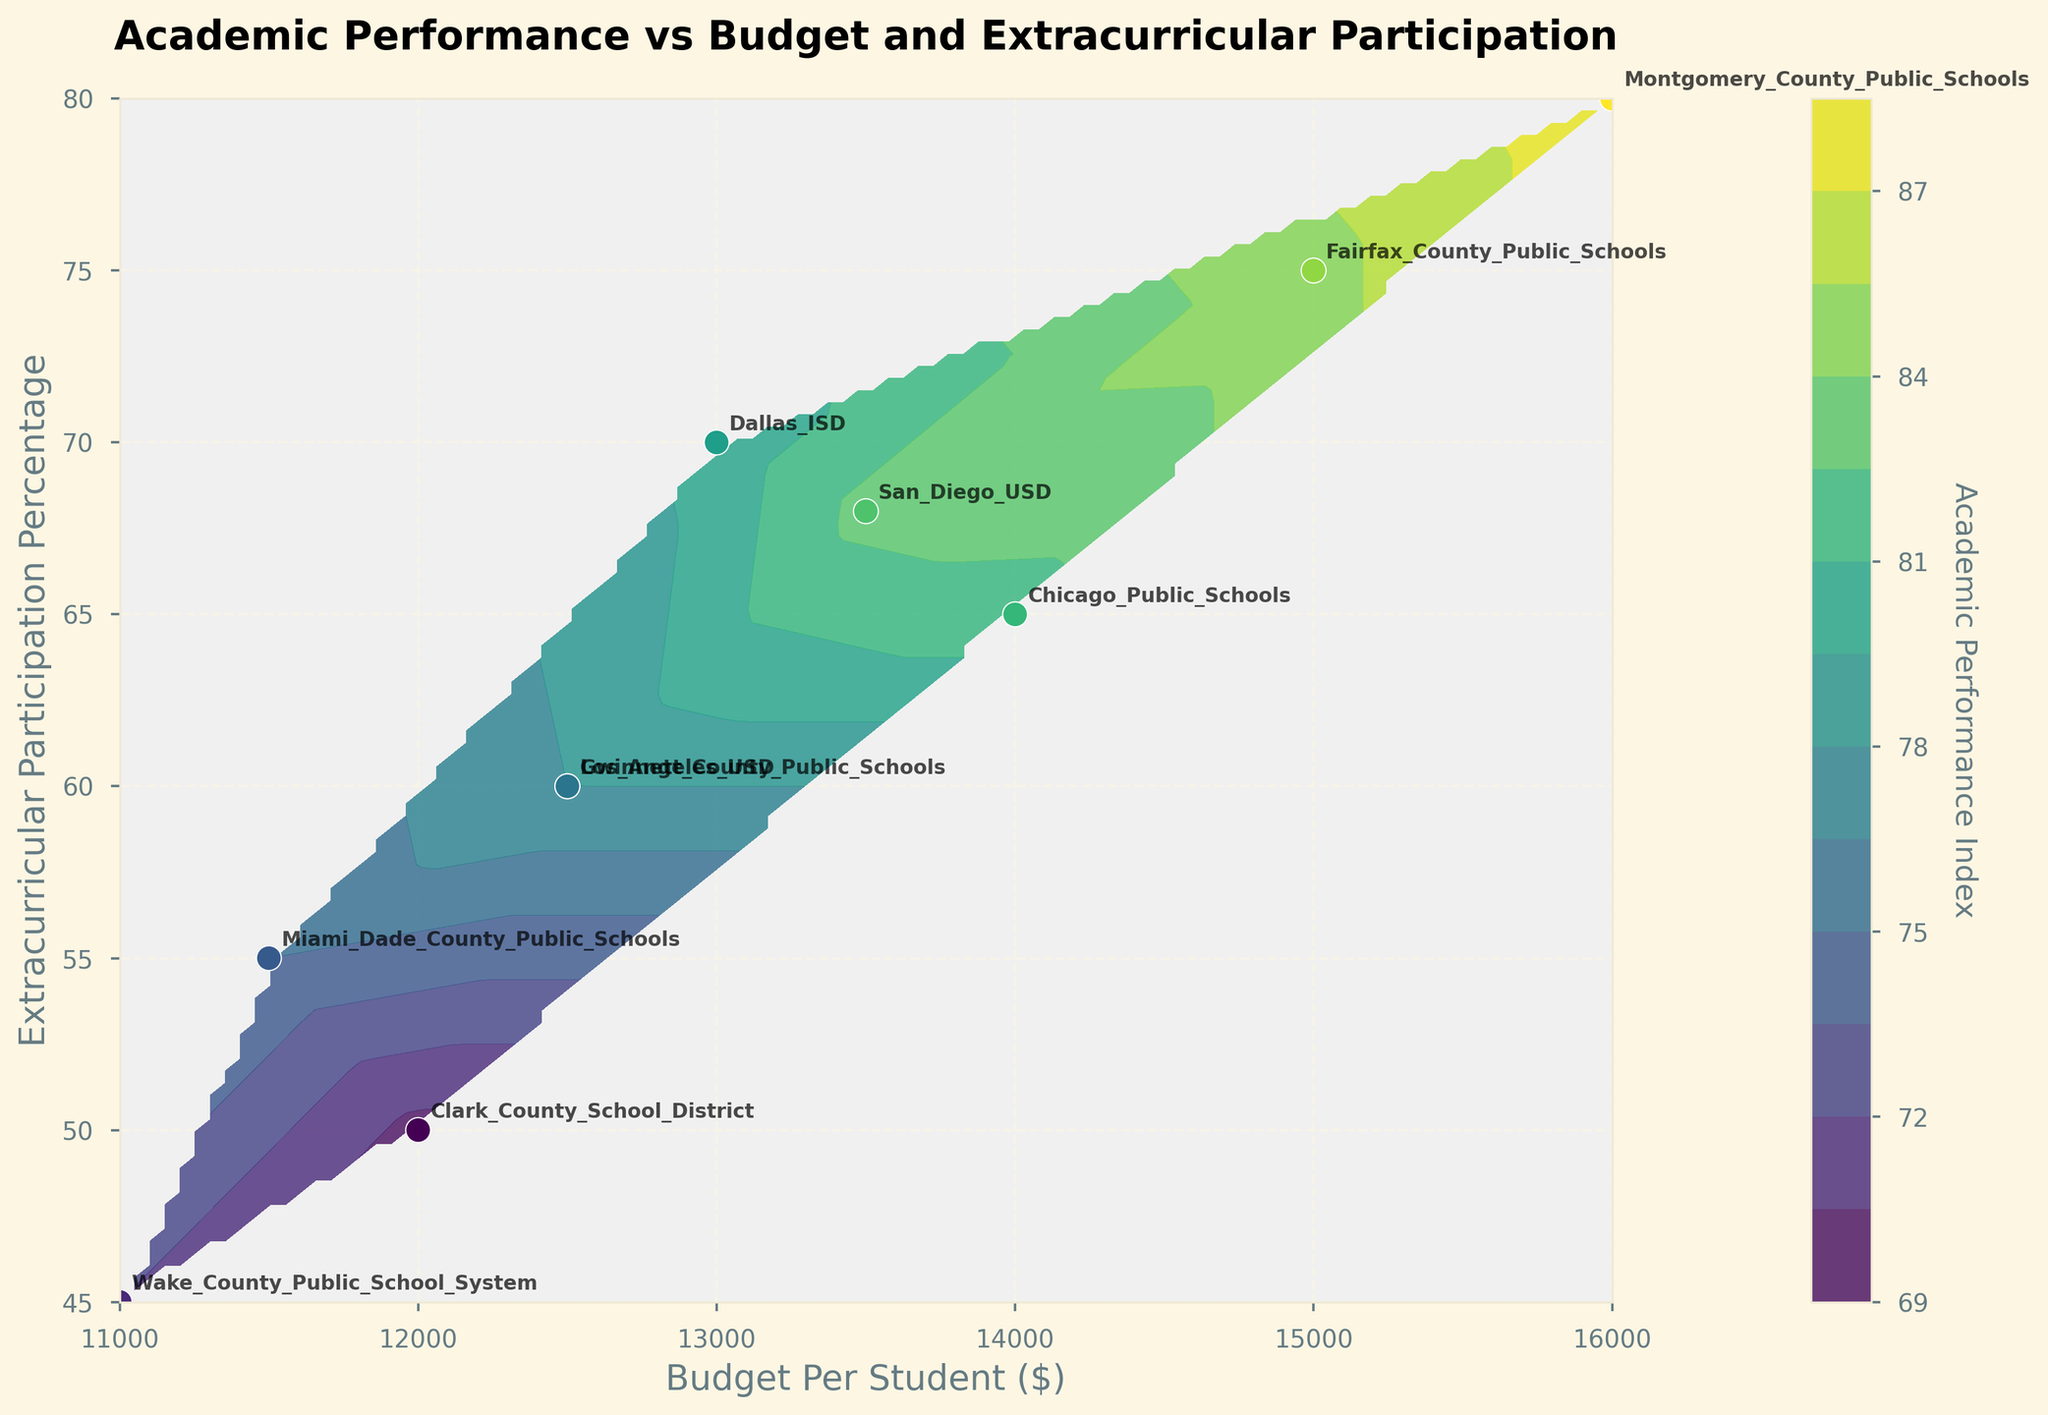What is the title of the figure? The title is located at the top of the figure, which is "Academic Performance vs Budget and Extracurricular Participation". This summarizes the main focus of the plot.
Answer: Academic Performance vs Budget and Extracurricular Participation What is the label for the x-axis? The label for the x-axis is found along the horizontal axis of the plot. It's "Budget Per Student ($)", indicating that this axis represents the budget per student in dollars.
Answer: Budget Per Student ($) Which school district has the highest extracurricular participation percentage? By looking at the scatter points with labels on the right side of the plot, the school with the highest participation percentage is Montgomery_County_Public_Schools with 80%.
Answer: Montgomery_County_Public_Schools How does the academic performance index change with increasing budget per student for a given extracurricular participation percentage? This requires observing the contour lines' behavior. Generally, the contours shift upwards (higher academic performance) as the budget per student increases, implying a positive correlation.
Answer: Increases For a school district with a budget of $12500 per student, what is the range of extracurricular participation percentages observed? Examine the x-axis at $12500 and look vertically to see two relevant points: Los_Angeles_USD and Gwinnett_County_Public_Schools, which have extracurricular participation of 60%.
Answer: 60% Which school districts fall within the same contour line representing an academic performance index of approximately 85? Looking at the contour line that corresponds with 85 on the color bar, the schools that lie on or near this contour are Fairfax_County_Public_Schools and San_Diego_USD.
Answer: Fairfax_County_Public_Schools, San_Diego_USD Compare the academic performance of Dallas_ISD and Clark_County_School_District. Which one performs better? By locating the scatter points and looking at the color or labels, Dallas_ISD has an academic performance index of 80, while Clark_County_School_District has 70, so Dallas_ISD performs better.
Answer: Dallas_ISD What is the median academic performance index of the listed school districts? List out the academic performance indices: 78, 82, 75, 80, 70, 85, 88, 83, 72, 77. Arrange them in ascending order: 70, 72, 75, 77, 78, 80, 82, 83, 85, 88. The median will be the average of the 5th and 6th values: (78 + 80)/2 = 79.
Answer: 79 